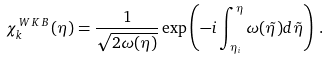Convert formula to latex. <formula><loc_0><loc_0><loc_500><loc_500>\chi ^ { \, W \, K \, B \, } _ { k } ( \eta ) = \frac { 1 } { \sqrt { 2 \omega ( \eta ) } } \exp \left ( - i \int ^ { \eta } _ { \eta _ { i } } \omega ( \tilde { \eta } ) d \tilde { \eta } \right ) \, .</formula> 